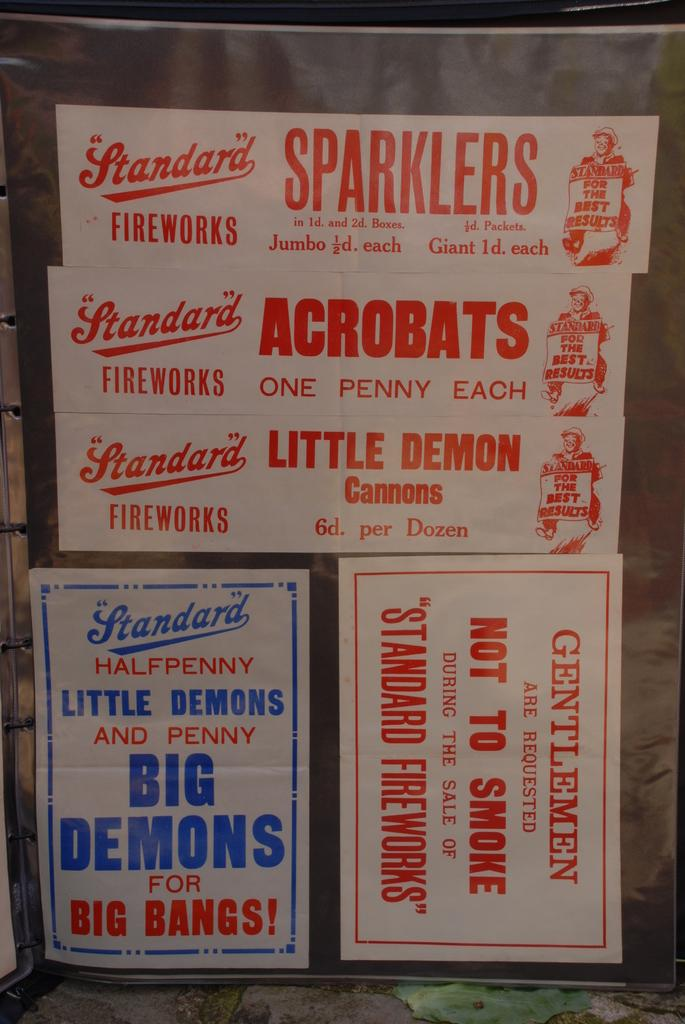<image>
Relay a brief, clear account of the picture shown. Boxes of fireworks, including sparklers and little demon cannons are stacked on top of each other 